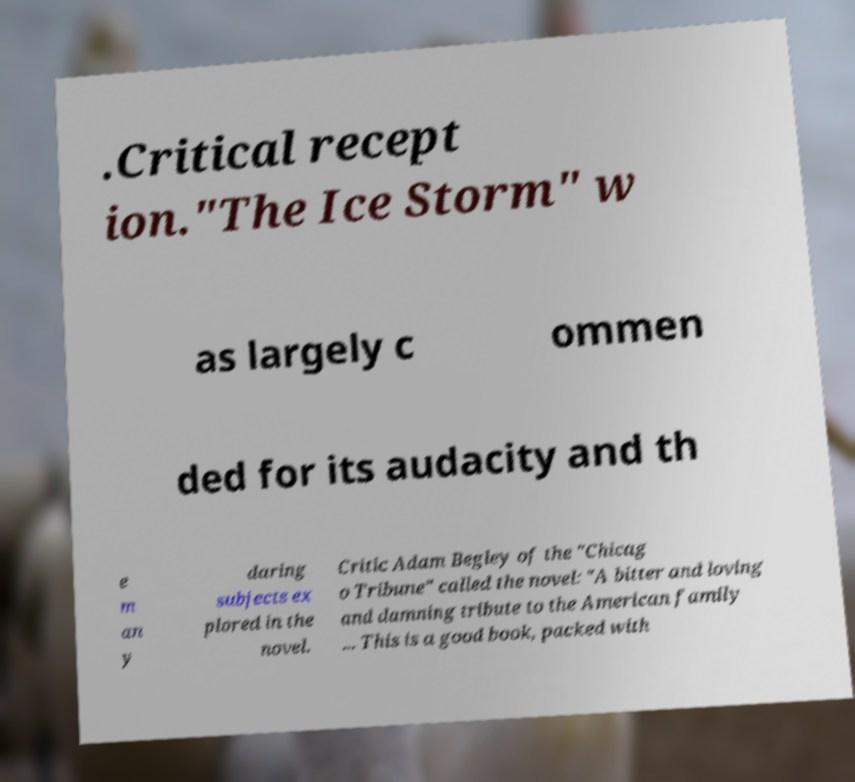For documentation purposes, I need the text within this image transcribed. Could you provide that? .Critical recept ion."The Ice Storm" w as largely c ommen ded for its audacity and th e m an y daring subjects ex plored in the novel. Critic Adam Begley of the "Chicag o Tribune" called the novel: "A bitter and loving and damning tribute to the American family ... This is a good book, packed with 